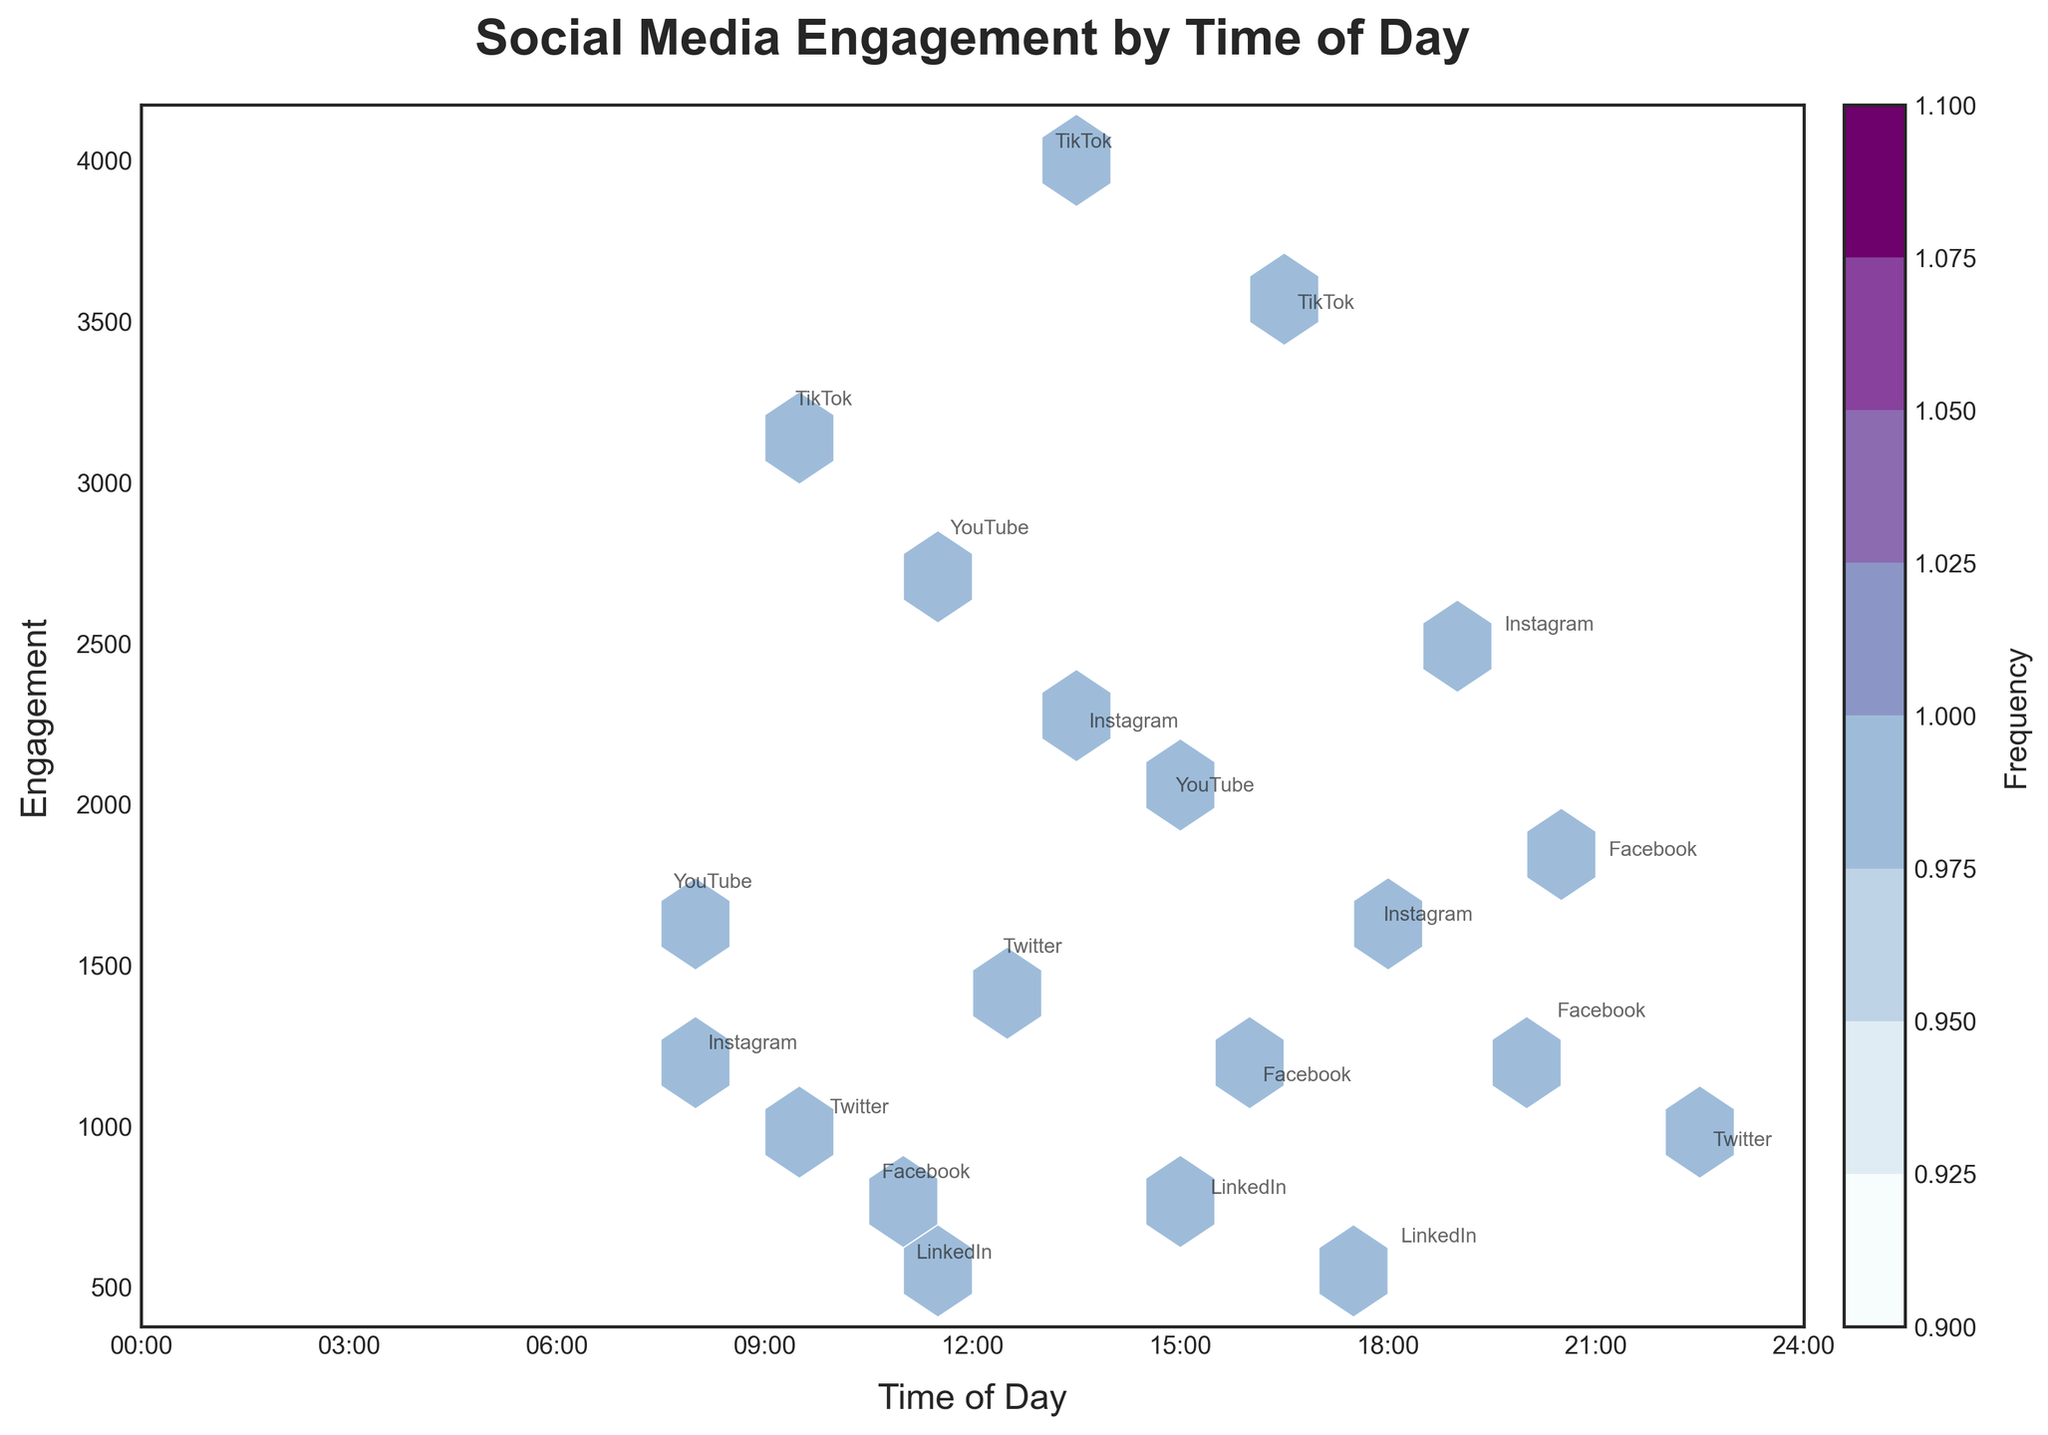What is the title of the plot? The title of the plot is prominently displayed at the top of the figure in a larger, bold font.
Answer: Social Media Engagement by Time of Day What do the x-axis and y-axis represent? The x-axis represents the "Time of Day" in hours, displayed at 3-hour intervals from 00:00 to 24:00. The y-axis represents "Engagement," which indicates the level of interaction each post received.
Answer: Time of Day, Engagement How does the engagement level vary throughout the day? By observing the density and frequency of hexbins, engagement levels seem to peak during late morning (around 10:30 to 11:30) and early evening (around 16:30 to 19:30).
Answer: Peaks in late morning and early evening Which platform had the highest engagement and at what time? By looking at the highest point on the y-axis labeled with platform names, TikTok at 13:00 had the highest engagement with an engagement value of 4000.
Answer: TikTok at 13:00 What is the color scale used to indicate the frequency in the plot? The color scale varies from light blue to dark purple, with darker shades indicating higher frequencies of data points.
Answer: Light blue to dark purple How many data points are represented in the plot? The number of hexbins with a plotted point inside them indicates the frequency of data points. The plot appears to have approximately 20 distinct hexbins, each representing at least one data point.
Answer: Approximately 20 Which content type had considerable engagement on Instagram and at what times? "Stories" at 17:45 had about 1600 engagements, and "Live_Stream" at 19:30 had about 2500 engagements. By annotating the platform names, these times and content types are clearly marked.
Answer: Stories at 17:45 and Live_Stream at 19:30 Are morning or evening posts more engaging on average? By comparing the density of hexbins in the morning (00:00 to 12:00) to the evening (12:00 to 24:00), there are generally more high engagement points in the evening, indicating higher engagement levels.
Answer: Evening Which platform and time combination showed the lowest engagement? LinkedIn at 11:00 shows the lowest engagement, with a value of 550. This can be identified by finding the lowest y-axis value labeled with a platform.
Answer: LinkedIn at 11:00 Are there any platforms that show consistent engagement throughout the day? Instagram shows multiple points spread throughout the day such as 8:00, 19:30, and 17:45 with various levels of engagement, indicating a more consistent engagement pattern.
Answer: Instagram 